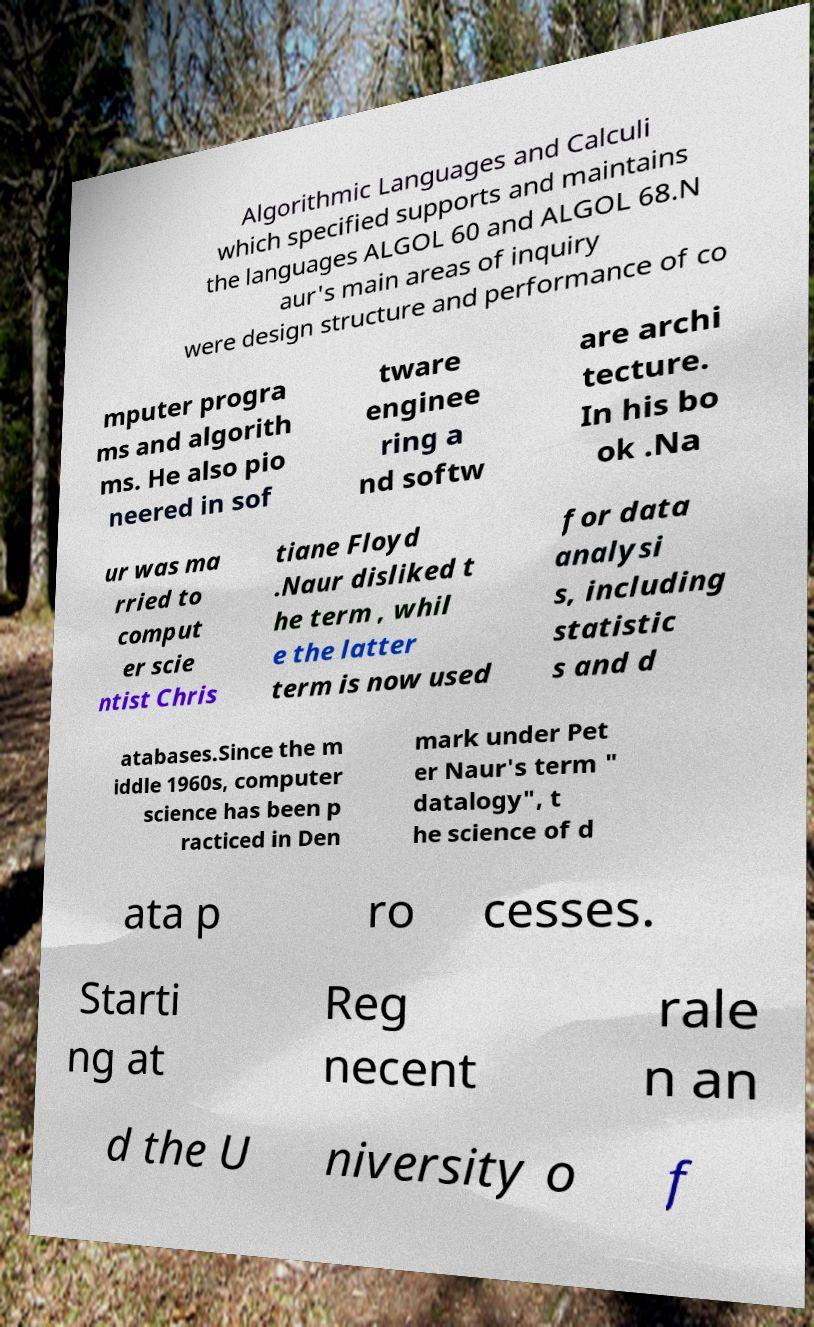What messages or text are displayed in this image? I need them in a readable, typed format. Algorithmic Languages and Calculi which specified supports and maintains the languages ALGOL 60 and ALGOL 68.N aur's main areas of inquiry were design structure and performance of co mputer progra ms and algorith ms. He also pio neered in sof tware enginee ring a nd softw are archi tecture. In his bo ok .Na ur was ma rried to comput er scie ntist Chris tiane Floyd .Naur disliked t he term , whil e the latter term is now used for data analysi s, including statistic s and d atabases.Since the m iddle 1960s, computer science has been p racticed in Den mark under Pet er Naur's term " datalogy", t he science of d ata p ro cesses. Starti ng at Reg necent rale n an d the U niversity o f 